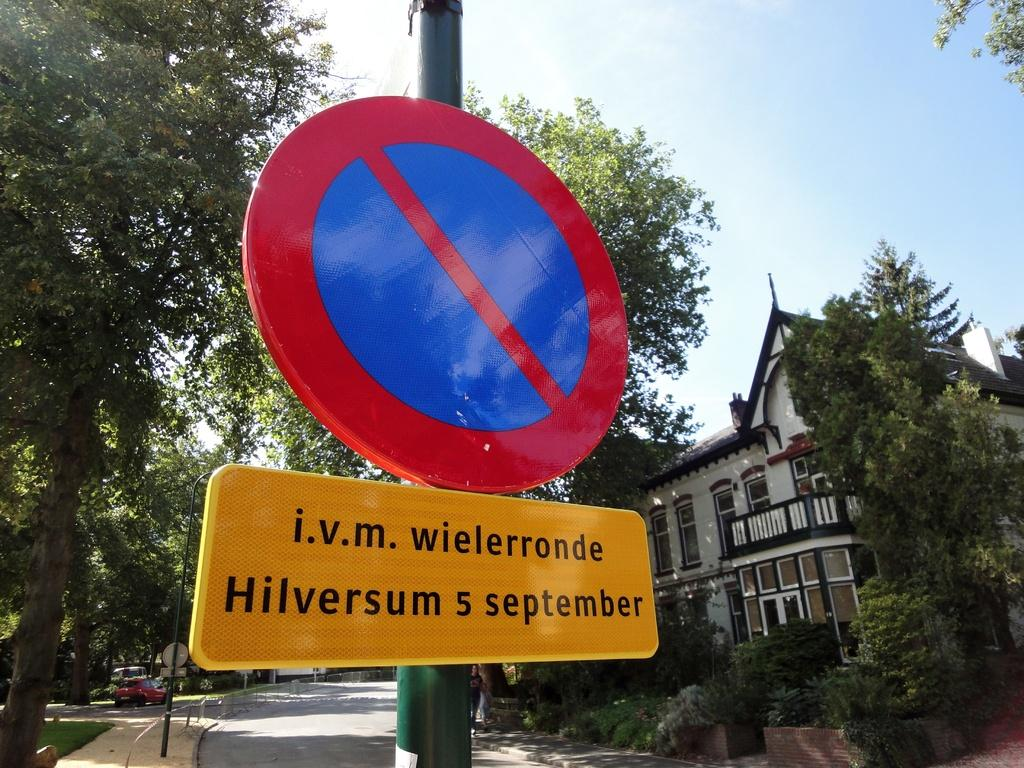<image>
Summarize the visual content of the image. Below a blue and red sign is a yellow one that reads "i.v.m. wielerronde Hilversum 5 september." 